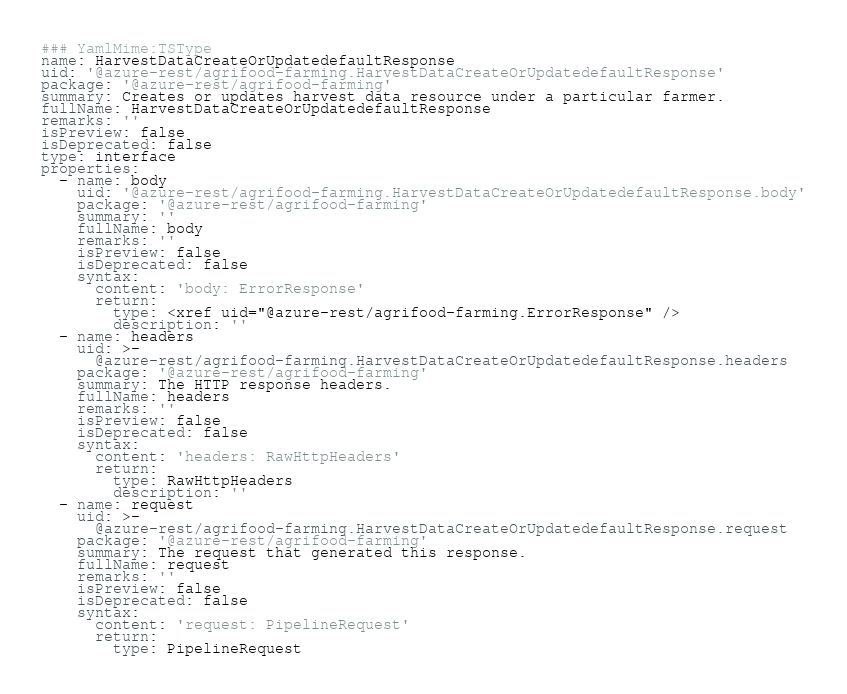<code> <loc_0><loc_0><loc_500><loc_500><_YAML_>### YamlMime:TSType
name: HarvestDataCreateOrUpdatedefaultResponse
uid: '@azure-rest/agrifood-farming.HarvestDataCreateOrUpdatedefaultResponse'
package: '@azure-rest/agrifood-farming'
summary: Creates or updates harvest data resource under a particular farmer.
fullName: HarvestDataCreateOrUpdatedefaultResponse
remarks: ''
isPreview: false
isDeprecated: false
type: interface
properties:
  - name: body
    uid: '@azure-rest/agrifood-farming.HarvestDataCreateOrUpdatedefaultResponse.body'
    package: '@azure-rest/agrifood-farming'
    summary: ''
    fullName: body
    remarks: ''
    isPreview: false
    isDeprecated: false
    syntax:
      content: 'body: ErrorResponse'
      return:
        type: <xref uid="@azure-rest/agrifood-farming.ErrorResponse" />
        description: ''
  - name: headers
    uid: >-
      @azure-rest/agrifood-farming.HarvestDataCreateOrUpdatedefaultResponse.headers
    package: '@azure-rest/agrifood-farming'
    summary: The HTTP response headers.
    fullName: headers
    remarks: ''
    isPreview: false
    isDeprecated: false
    syntax:
      content: 'headers: RawHttpHeaders'
      return:
        type: RawHttpHeaders
        description: ''
  - name: request
    uid: >-
      @azure-rest/agrifood-farming.HarvestDataCreateOrUpdatedefaultResponse.request
    package: '@azure-rest/agrifood-farming'
    summary: The request that generated this response.
    fullName: request
    remarks: ''
    isPreview: false
    isDeprecated: false
    syntax:
      content: 'request: PipelineRequest'
      return:
        type: PipelineRequest</code> 